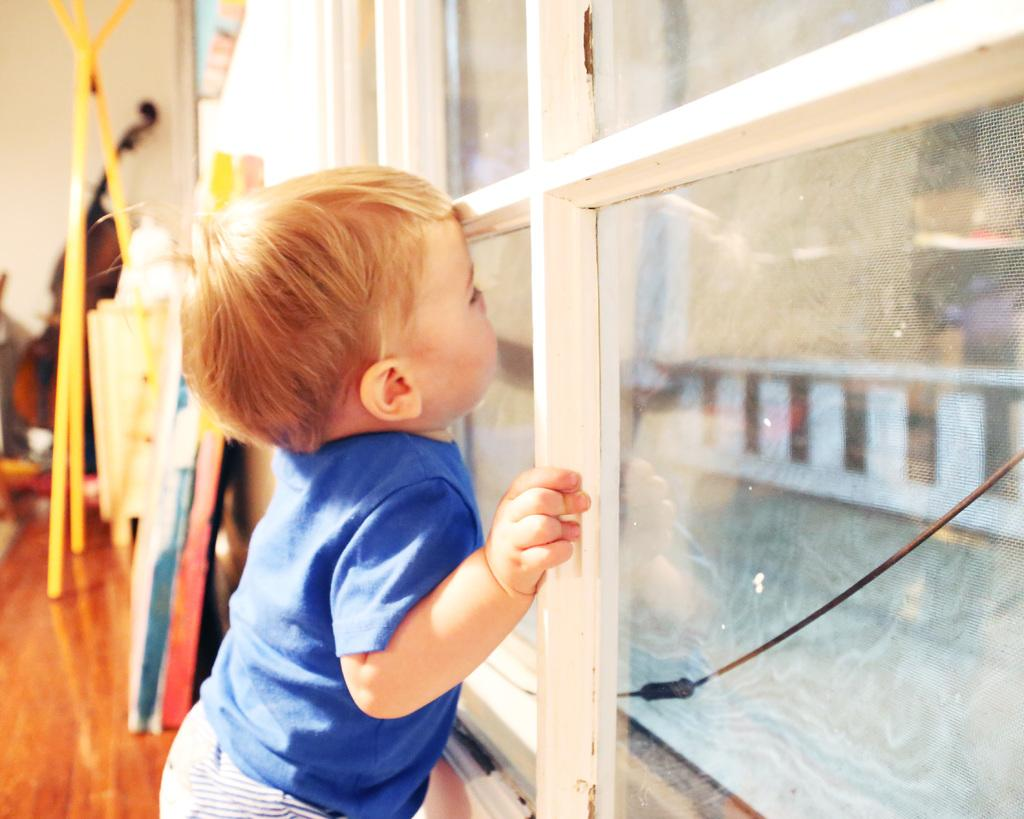Who is the main subject in the image? There is a boy in the image. What is the boy wearing? The boy is wearing a blue t-shirt. What is the boy standing near? The boy is standing near a glass. What can be seen in the background of the image? There are leaders and other objects visible in the background of the image. What type of nerve can be seen in the image? There is no nerve present in the image; it features a boy wearing a blue t-shirt, standing near a glass, and a background with leaders and other objects. 